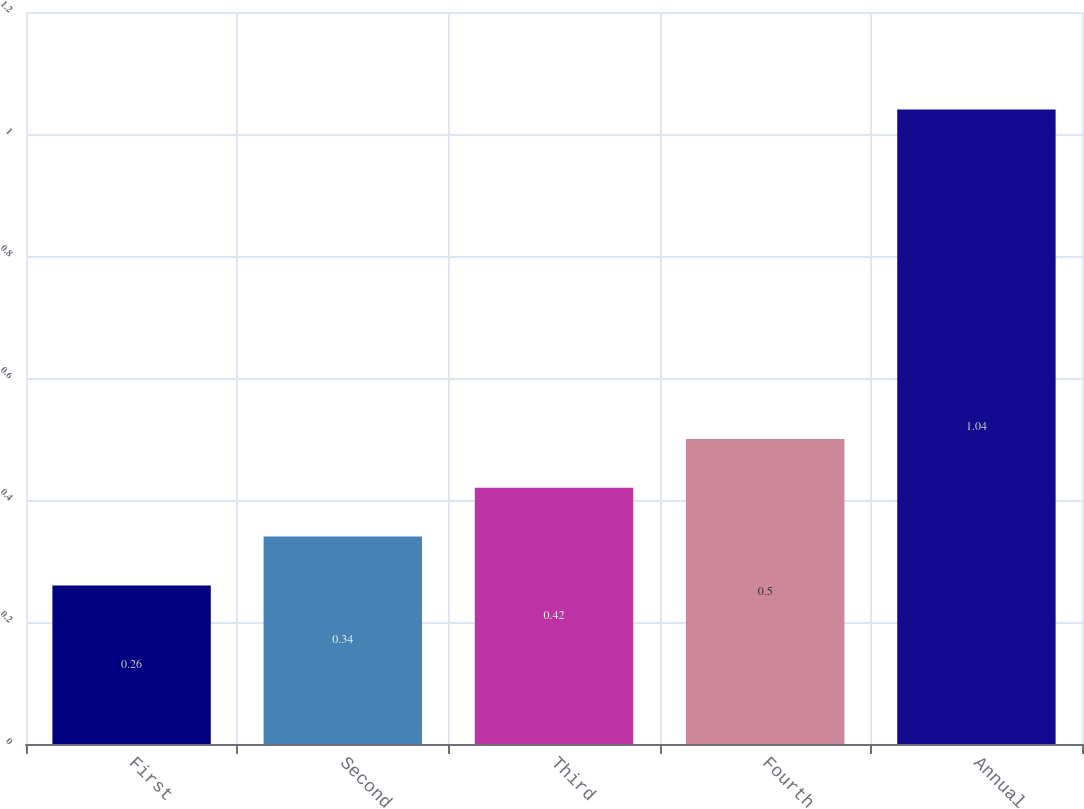Convert chart to OTSL. <chart><loc_0><loc_0><loc_500><loc_500><bar_chart><fcel>First<fcel>Second<fcel>Third<fcel>Fourth<fcel>Annual<nl><fcel>0.26<fcel>0.34<fcel>0.42<fcel>0.5<fcel>1.04<nl></chart> 